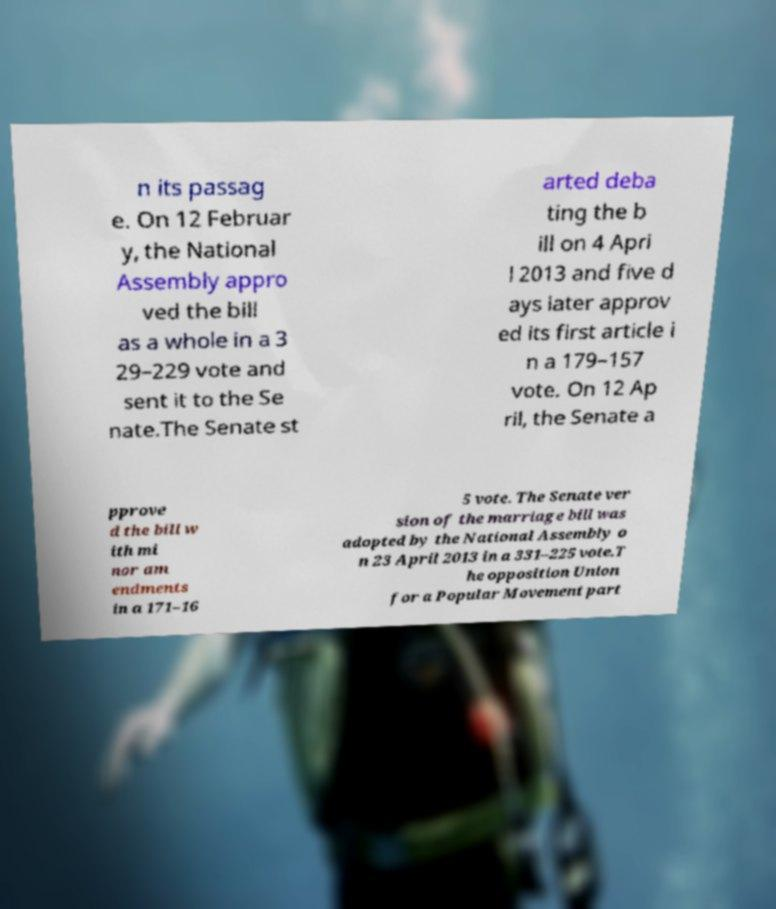Can you accurately transcribe the text from the provided image for me? n its passag e. On 12 Februar y, the National Assembly appro ved the bill as a whole in a 3 29–229 vote and sent it to the Se nate.The Senate st arted deba ting the b ill on 4 Apri l 2013 and five d ays later approv ed its first article i n a 179–157 vote. On 12 Ap ril, the Senate a pprove d the bill w ith mi nor am endments in a 171–16 5 vote. The Senate ver sion of the marriage bill was adopted by the National Assembly o n 23 April 2013 in a 331–225 vote.T he opposition Union for a Popular Movement part 